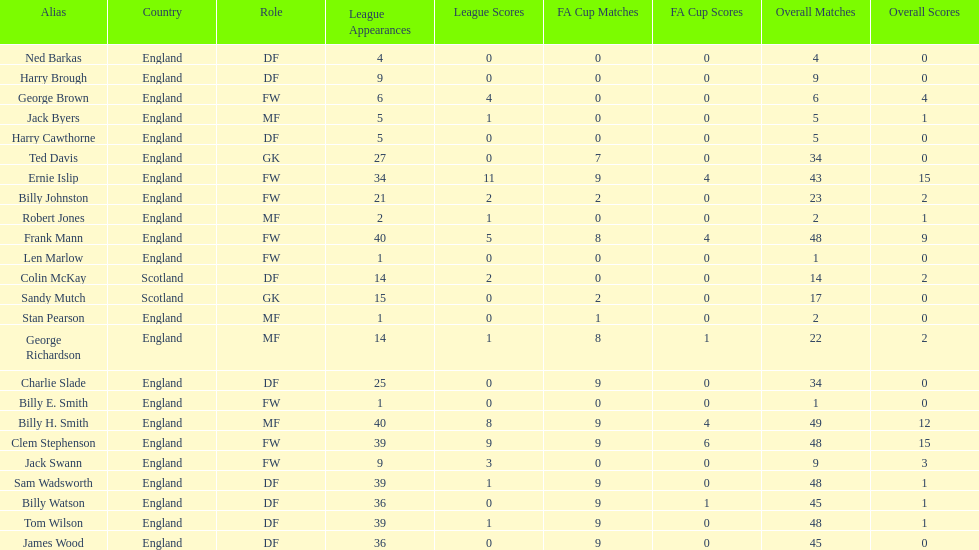What are the total league apps owned by ted davis? 27. 